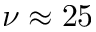Convert formula to latex. <formula><loc_0><loc_0><loc_500><loc_500>\nu \approx 2 5</formula> 